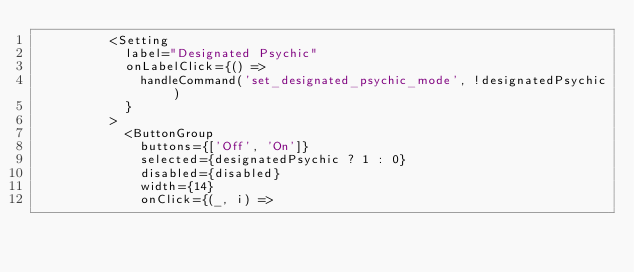Convert code to text. <code><loc_0><loc_0><loc_500><loc_500><_TypeScript_>          <Setting
            label="Designated Psychic"
            onLabelClick={() =>
              handleCommand('set_designated_psychic_mode', !designatedPsychic)
            }
          >
            <ButtonGroup
              buttons={['Off', 'On']}
              selected={designatedPsychic ? 1 : 0}
              disabled={disabled}
              width={14}
              onClick={(_, i) =></code> 